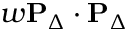<formula> <loc_0><loc_0><loc_500><loc_500>w P _ { \Delta } \cdot P _ { \Delta }</formula> 